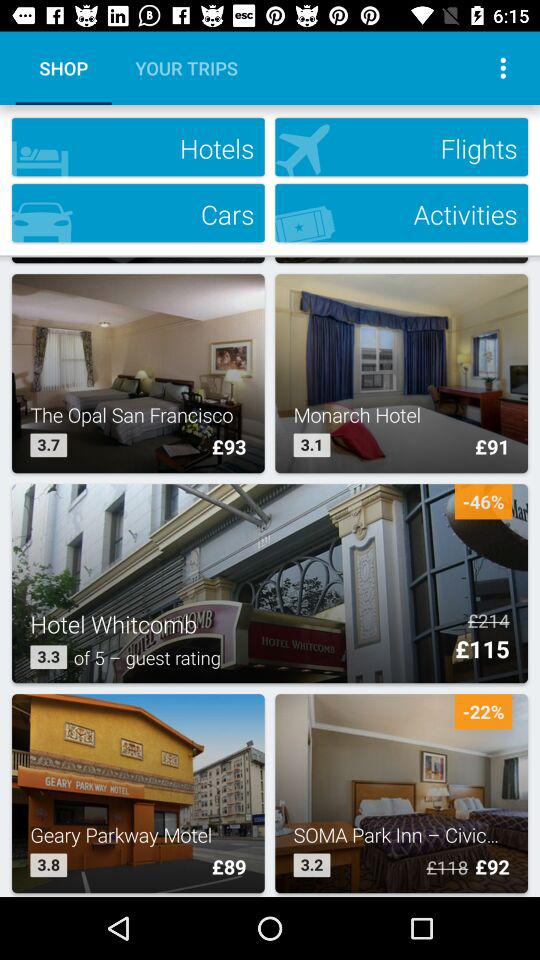Which are the different hotels? The different hotels are "The Opal San Francisco", "Monarch Hotel", "Hotel Whitcomb", "Geary Parkway Motel" and "SOMA Park Inn – Civic...". 